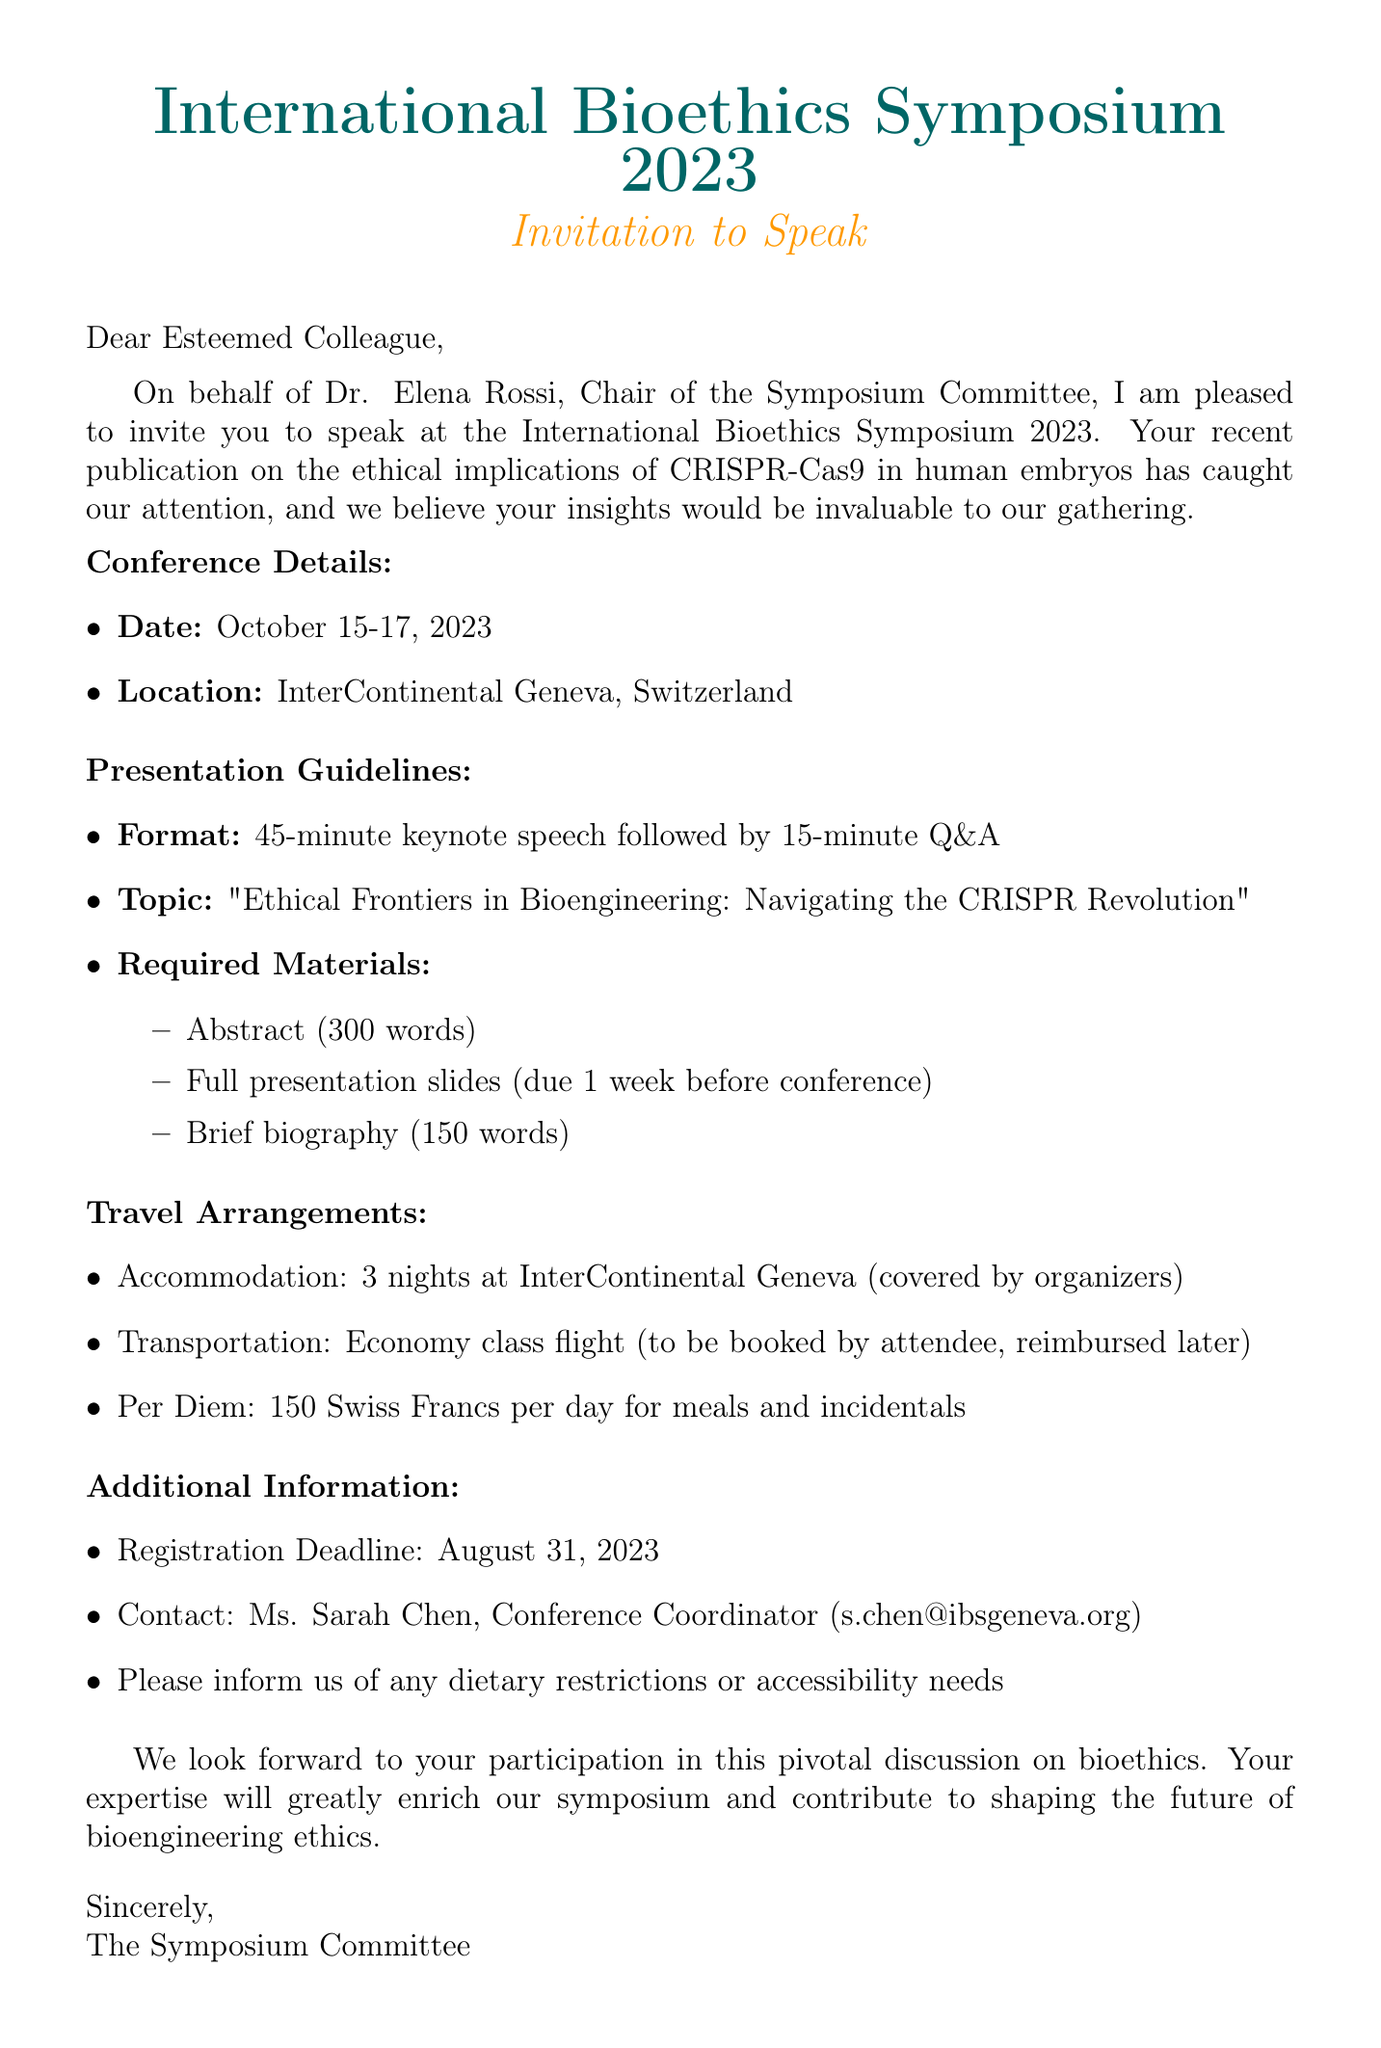What are the dates of the conference? The dates of the conference are specified as October 15-17, 2023.
Answer: October 15-17, 2023 Who invited the recipient to speak? The document states that Dr. Elena Rossi, Chair of the Symposium Committee, invited the recipient.
Answer: Dr. Elena Rossi What is the presentation format? The presentation format outlined in the document is a 45-minute keynote speech followed by a 15-minute Q&A.
Answer: 45-minute keynote speech followed by 15-minute Q&A What is the reimbursement for meals and incidentals? The per diem for meals and incidentals is mentioned as 150 Swiss Francs per day in the travel arrangements.
Answer: 150 Swiss Francs When is the registration deadline? The registration deadline is given in the additional information section as August 31, 2023.
Answer: August 31, 2023 What is the main topic of the keynote speech? The document specifies the topic of the keynote speech as "Ethical Frontiers in Bioengineering: Navigating the CRISPR Revolution."
Answer: Ethical Frontiers in Bioengineering: Navigating the CRISPR Revolution What should the abstract be limited to? The document states that the abstract should be limited to 300 words.
Answer: 300 words What is required to be submitted a week before the conference? The full presentation slides are required to be submitted one week before the conference, as specified in the guidelines.
Answer: Full presentation slides How many nights will be covered for accommodation? The travel arrangements indicate that 3 nights at the InterContinental Geneva will be covered by the organizers.
Answer: 3 nights Who is the contact person for the conference? The document lists Ms. Sarah Chen as the contact person for the conference.
Answer: Ms. Sarah Chen 